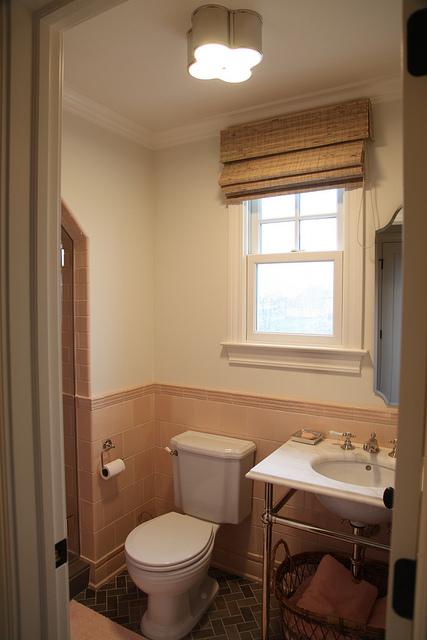What is the color of the wall?
Keep it brief. White. Where are the lights?
Quick response, please. Ceiling. Is there a bucket?
Give a very brief answer. No. Is there any light in the bathroom?
Give a very brief answer. Yes. What is this room?
Quick response, please. Bathroom. What is under the sink?
Give a very brief answer. Basket. 